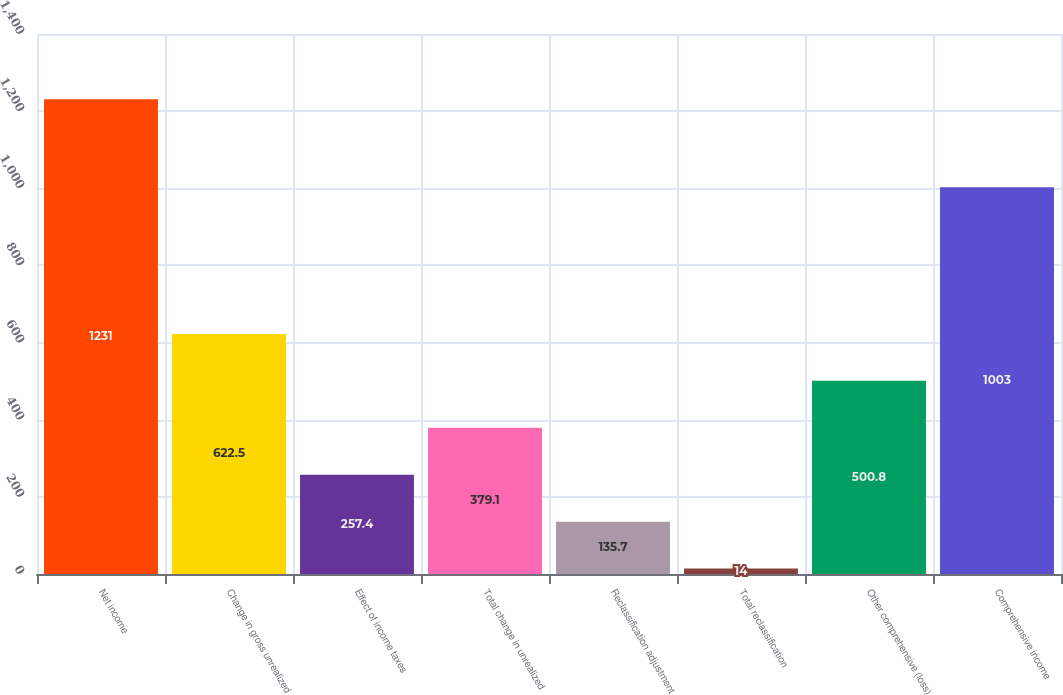Convert chart. <chart><loc_0><loc_0><loc_500><loc_500><bar_chart><fcel>Net income<fcel>Change in gross unrealized<fcel>Effect of income taxes<fcel>Total change in unrealized<fcel>Reclassification adjustment<fcel>Total reclassification<fcel>Other comprehensive (loss)<fcel>Comprehensive income<nl><fcel>1231<fcel>622.5<fcel>257.4<fcel>379.1<fcel>135.7<fcel>14<fcel>500.8<fcel>1003<nl></chart> 